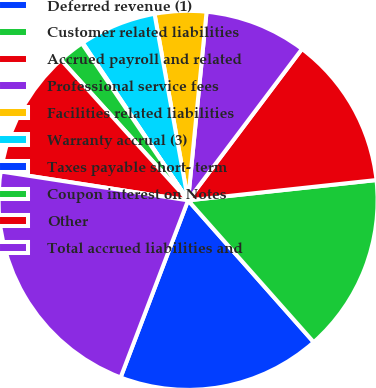<chart> <loc_0><loc_0><loc_500><loc_500><pie_chart><fcel>Deferred revenue (1)<fcel>Customer related liabilities<fcel>Accrued payroll and related<fcel>Professional service fees<fcel>Facilities related liabilities<fcel>Warranty accrual (3)<fcel>Taxes payable short- term<fcel>Coupon interest on Notes<fcel>Other<fcel>Total accrued liabilities and<nl><fcel>17.33%<fcel>15.17%<fcel>13.02%<fcel>8.71%<fcel>4.39%<fcel>6.55%<fcel>0.08%<fcel>2.24%<fcel>10.86%<fcel>21.64%<nl></chart> 